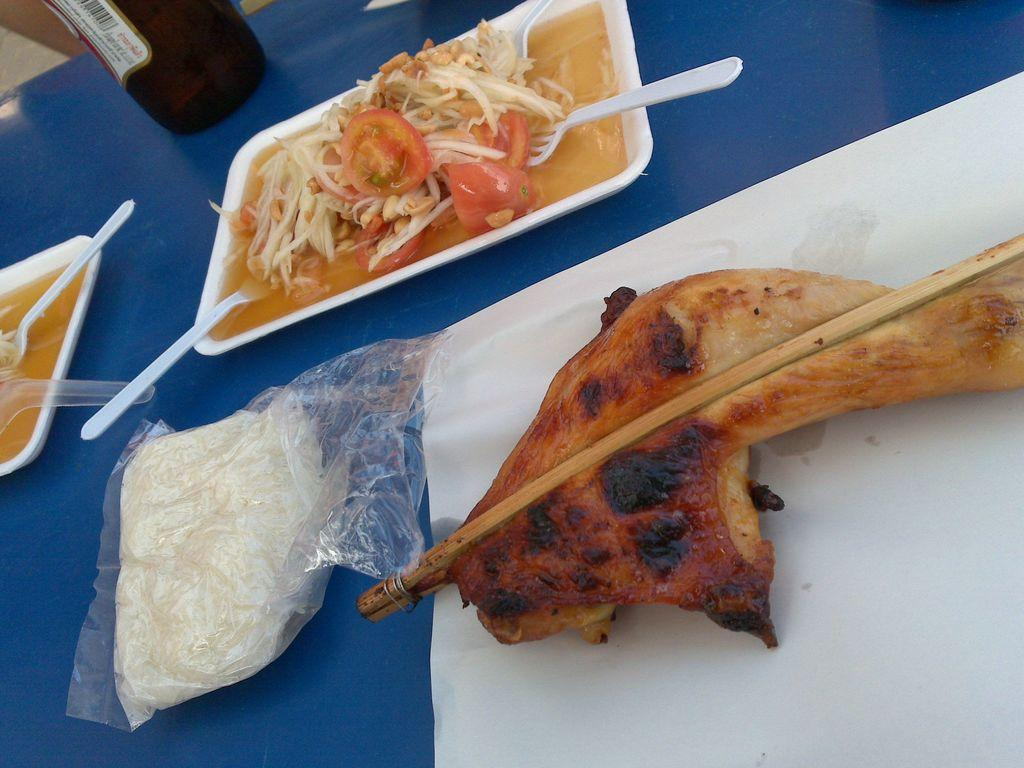What type of furniture is present in the image? There is a table in the image. What is placed on the table? There are food items on the table. Can you describe the contents of the trays on the table? There is a tray with noodles and tomato soup, and another tray with meat. What flavor of ice cream is being served on the table? There is no ice cream present on the table in the image. 